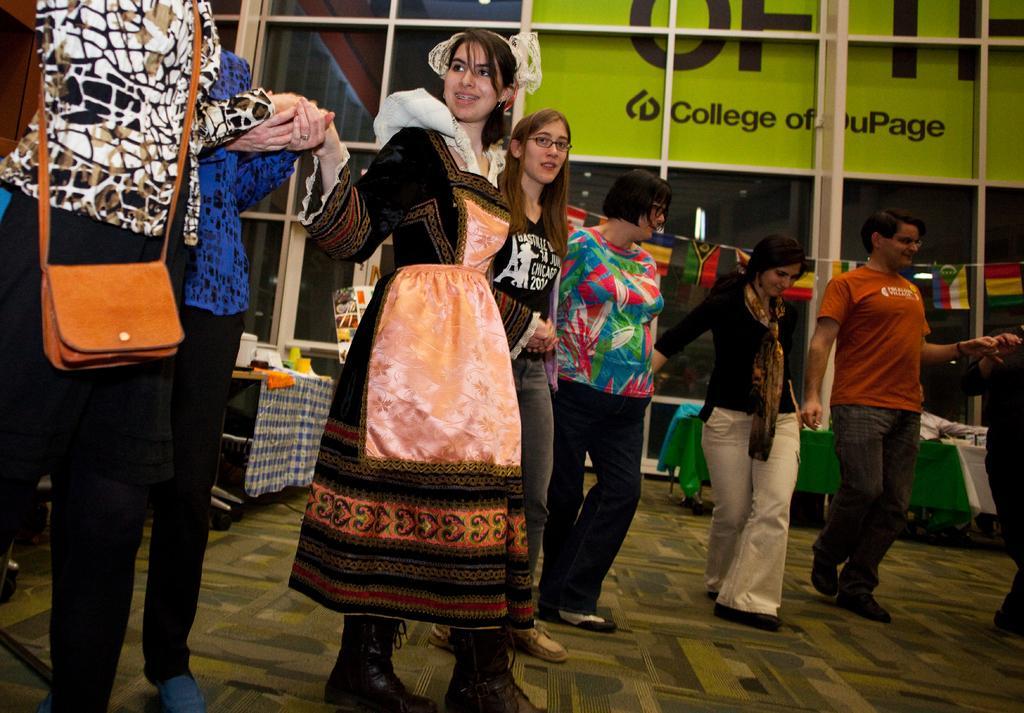Could you give a brief overview of what you see in this image? This picture describes about group of people, on the left side of the image we can see a woman, she wore a bag, in the background we can see few flags, lights, hoarding and few things on the tables, and also we can see few metal rods. 